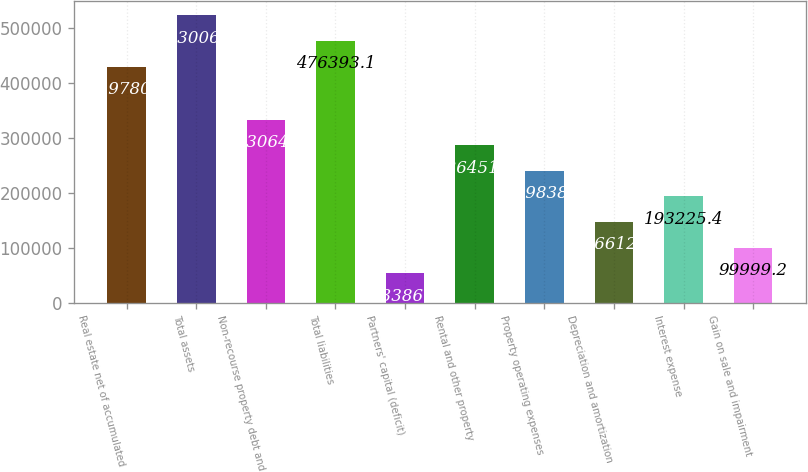Convert chart. <chart><loc_0><loc_0><loc_500><loc_500><bar_chart><fcel>Real estate net of accumulated<fcel>Total assets<fcel>Non-recourse property debt and<fcel>Total liabilities<fcel>Partners' capital (deficit)<fcel>Rental and other property<fcel>Property operating expenses<fcel>Depreciation and amortization<fcel>Interest expense<fcel>Gain on sale and impairment<nl><fcel>429780<fcel>523006<fcel>333065<fcel>476393<fcel>53386.1<fcel>286452<fcel>239838<fcel>146612<fcel>193225<fcel>99999.2<nl></chart> 